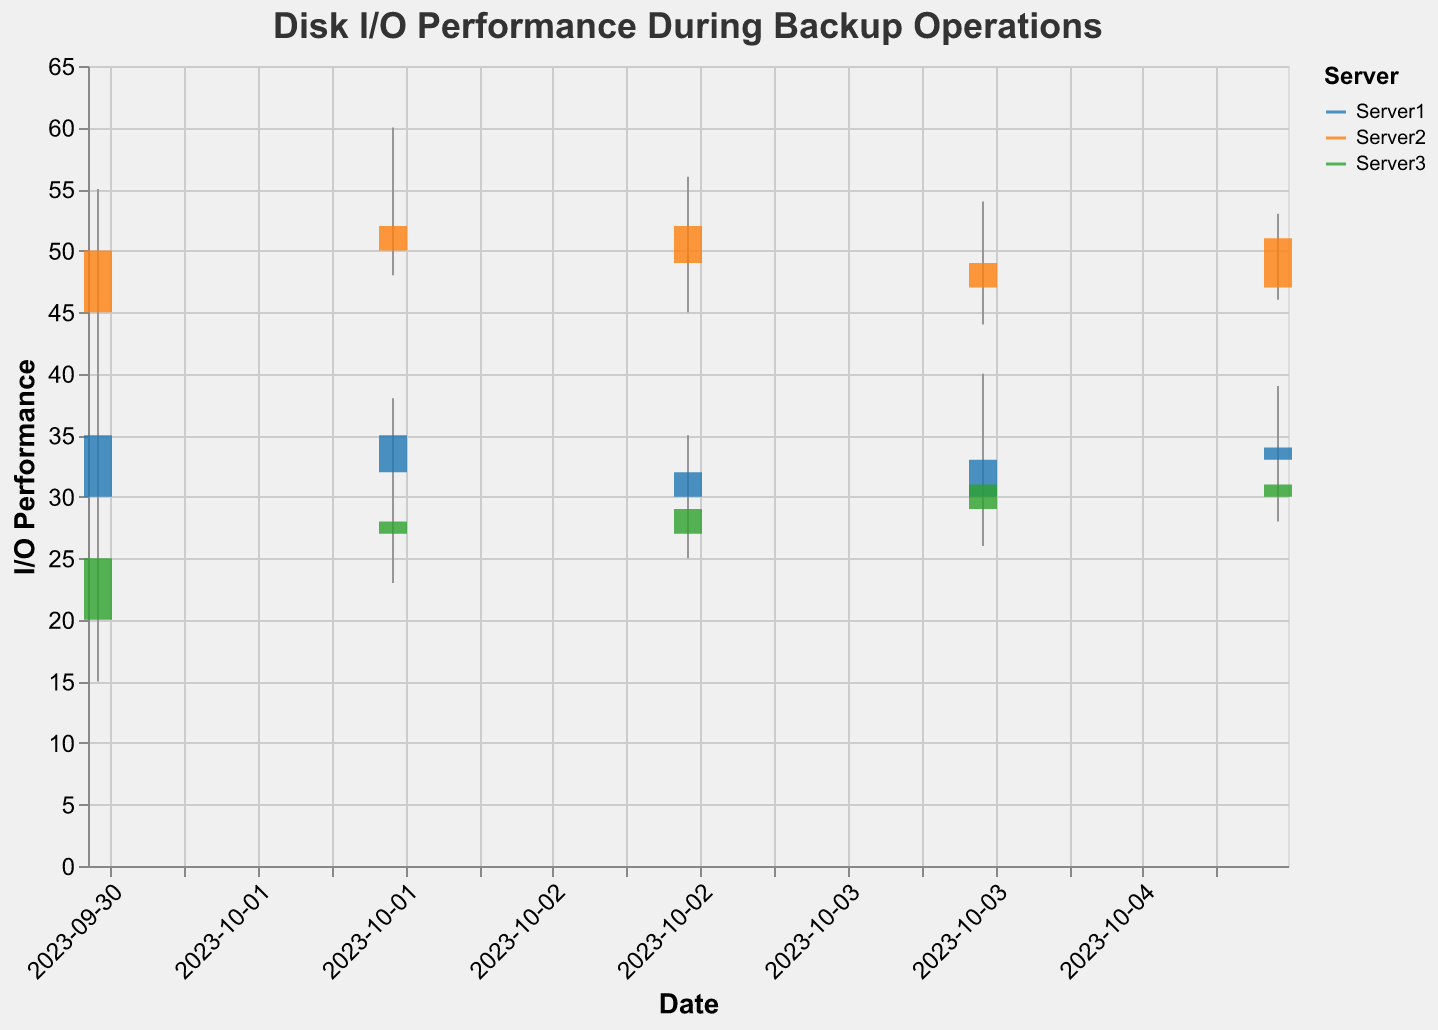What is the title of the plot? The plot title is displayed at the top of the figure, specifying the context of the data presented.
Answer: Disk I/O Performance During Backup Operations Which server has the highest Close value on 2023-10-02? Check the Close values for each server on the specified date and identify the maximum. Server2 has the highest Close value of 52.
Answer: Server2 What is the I/O Performance range for Server1 on 2023-10-01? Look at the High and Low values for Server1 on 2023-10-01. The range is found by subtracting Low from High. The High is 40, and the Low is 25, so the range is 40 - 25 = 15.
Answer: 15 Which server had the largest drop in I/O Performance on 2023-10-03? Compare the Open and Close values for each server on 2023-10-03. Calculate the difference (Open - Close) for each server. Server1 had a drop of 32 - 30 = 2, Server2 had a drop of 52 - 49 = 3, and Server3 had an increase (30 - 29 = 1). Server2 had the largest drop.
Answer: Server2 What was the average High value across all servers on 2023-10-04? Find the High values for all servers on the specified date: Server1 (40), Server2 (54), Server3 (34). Average them: (40 + 54 + 34) / 3 = 42.67.
Answer: 42.67 Which server had the most consistent I/O Performance from 2023-10-01 to 2023-10-05? Consistency can be assessed by the smallest variation (difference between High and Low). Calculate the average range (High - Low) for each server over the dates and compare. Server1: (40-25)+(38-28)+(35-29)+(40-28)+(39-31) = 15+10+6+12+8 = 51/5 = 10.2, Server2: (55-40)+(60-48)+(56-45)+(54-44)+(53-46) = 15+12+11+10+7 = 55/5 = 11, Server3: (30-15)+(33-23)+(32-25)+(34-26)+(36-28) = 15+10+7+8+8 = 48/5 = 9.6. Server3 had the smallest average range (9.6).
Answer: Server3 On which date did Server2 have the highest High value? Check the High values for Server2 across all dates and identify the maximum. The highest High value is 60 on 2023-10-02.
Answer: 2023-10-02 What's the total Low value for all servers on 2023-10-05? Sum the Low values for each server on 2023-10-05: Server1 (31), Server2 (46), Server3 (28). The total is 31 + 46 + 28 = 105.
Answer: 105 